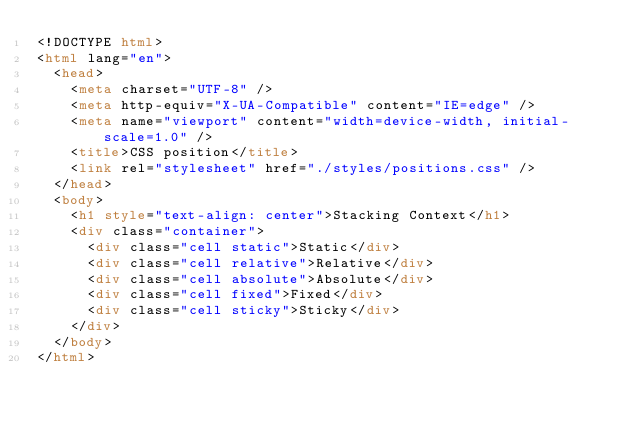Convert code to text. <code><loc_0><loc_0><loc_500><loc_500><_HTML_><!DOCTYPE html>
<html lang="en">
  <head>
    <meta charset="UTF-8" />
    <meta http-equiv="X-UA-Compatible" content="IE=edge" />
    <meta name="viewport" content="width=device-width, initial-scale=1.0" />
    <title>CSS position</title>
    <link rel="stylesheet" href="./styles/positions.css" />
  </head>
  <body>
    <h1 style="text-align: center">Stacking Context</h1>
    <div class="container">
      <div class="cell static">Static</div>
      <div class="cell relative">Relative</div>
      <div class="cell absolute">Absolute</div>
      <div class="cell fixed">Fixed</div>
      <div class="cell sticky">Sticky</div>
    </div>
  </body>
</html>
</code> 